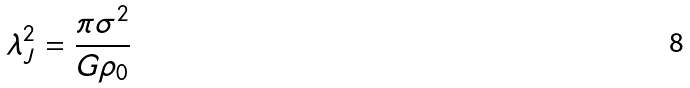Convert formula to latex. <formula><loc_0><loc_0><loc_500><loc_500>\lambda _ { J } ^ { 2 } = \frac { \pi \sigma ^ { 2 } } { G \rho _ { 0 } }</formula> 